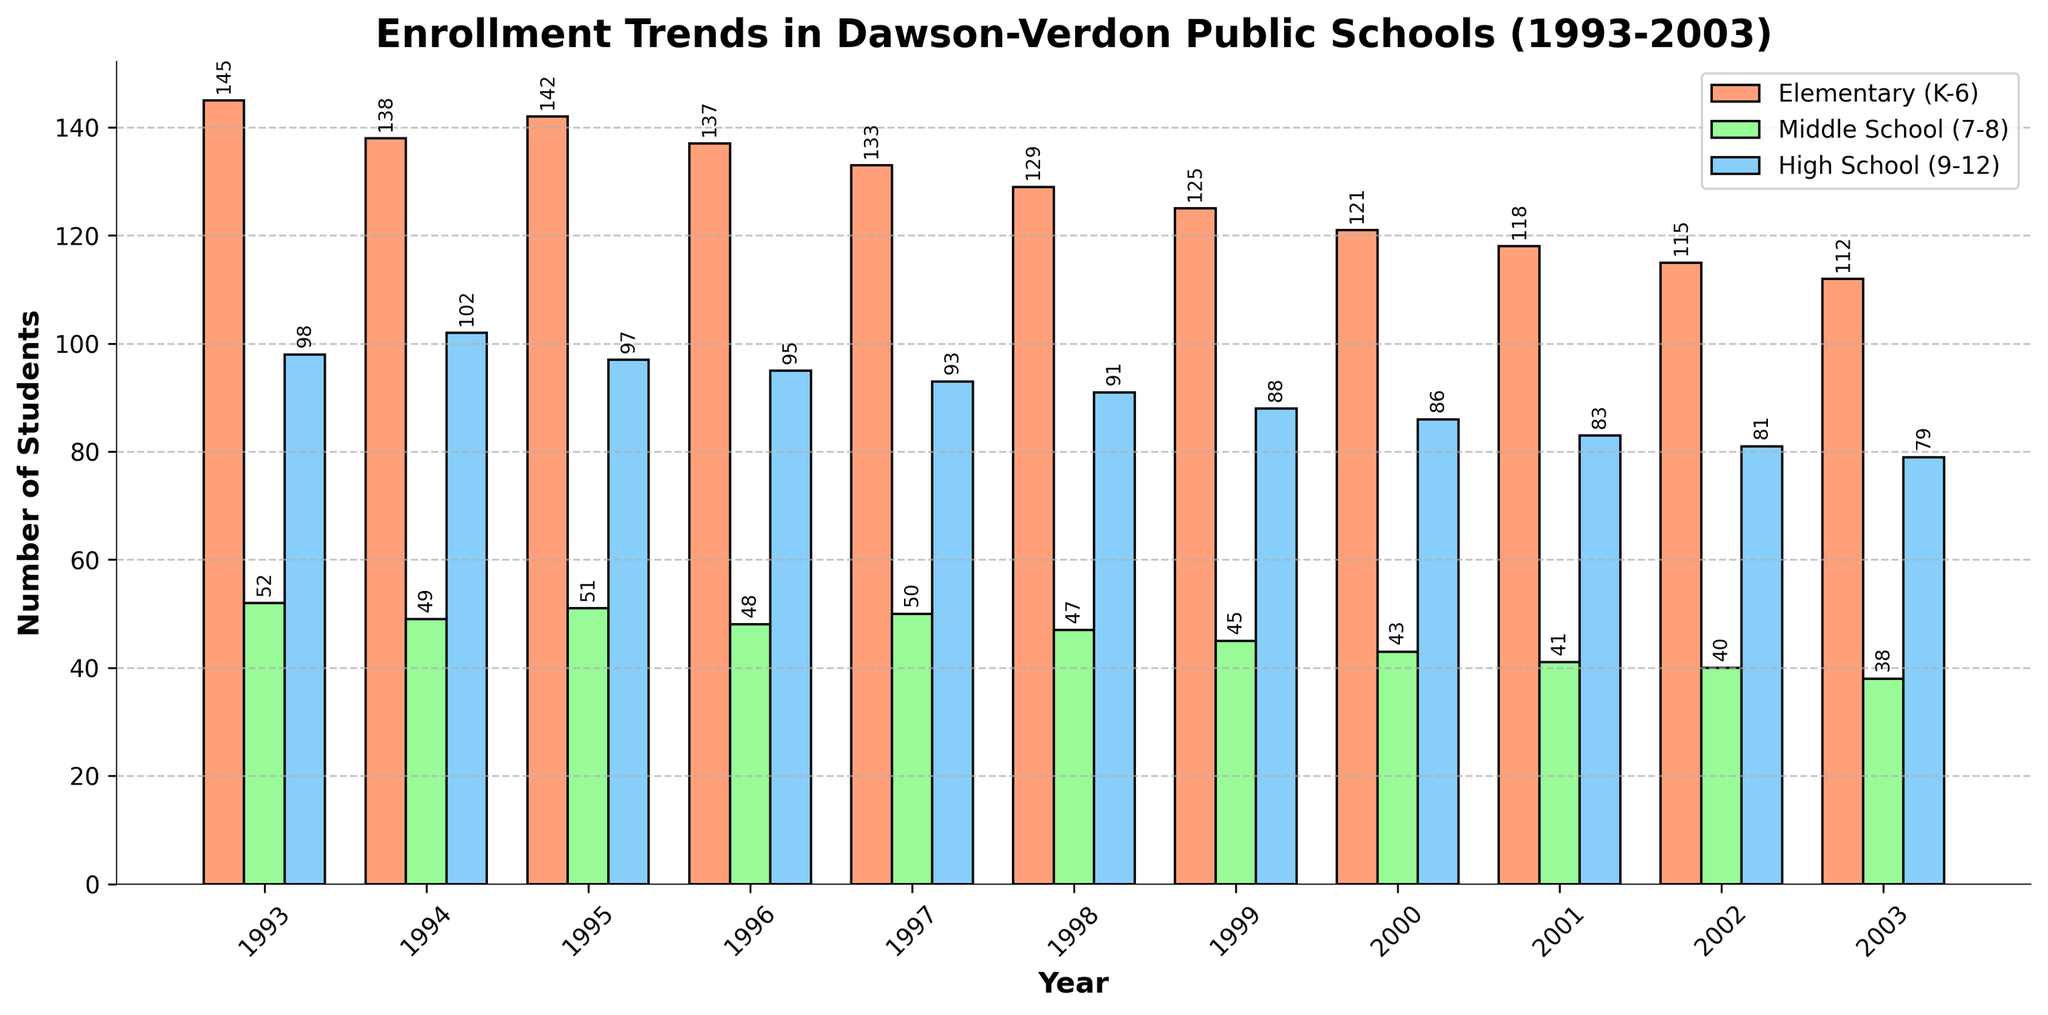What's the trend of total enrollment from 1993 to 2003? To analyze the trend, observe the heights of the bars representing the total number of students each year in the figure. Here, note that the total enrollment decreases each year from 295 in 1993 to 229 in 2003.
Answer: Decreasing trend Which grade level saw the largest decline in enrollment from 1993 to 2003? Compare the heights of the three groups of bars for 1993 and 2003. The difference in height is greatest for Elementary (K-6), which decreases from 145 in 1993 to 112 in 2003.
Answer: Elementary (K-6) What is the combined enrollment for Middle School (7-8) and High School (9-12) in 1996? Add the heights of the bars for Middle School (7-8) and High School (9-12) in 1996. The enrollment values are 48 for Middle School and 95 for High School. So, 48 + 95 = 143.
Answer: 143 In which year did the total enrollment first drop below 250? Locate the point where the total number of students' bar dips below 250. This happens in 2000, with 250 students. In the following years, it continues to be below 250.
Answer: 2001 Which grade level had the most stable enrollment over the years? Assess the fluctuation in the heights of bars for Elementary, Middle, and High School. Middle School (7-8) fluctuates the least from 52 in 1993 to 38 in 2003.
Answer: Middle School (7-8) If you combine the enrollment of Elementary and High School in 2002, does it exceed the total enrollment of 1993? First, add Elementary (115) and High School (81) enrollments in 2002, resulting in 115 + 81 = 196. Then, compare this with total enrollment in 1993, which is 295.
Answer: No, 196 < 295 By how much did the total enrollment decrease from 1993 to 1999? Subtract the total enrollment in 1999 from that in 1993. Total enrollment in 1993 is 295 and in 1999 is 258. So, 295 - 258 = 37.
Answer: 37 Which year had the highest enrollment for High School, and what was the enrollment number? Find the tallest bar for High School enrollment over the years. The tallest bar is in 1994 with 102 students enrolled.
Answer: 1994, 102 students How many students were enrolled in Middle School in 2001, and how does it compare to its enrollment in 1997? Look for the heights of the Middle School bars in 2001 and 1997. Enrollment in 2001 is 41 and in 1997 is 50. So, 50 - 41 = 9, indicating a decrease.
Answer: 41; decreased by 9 Is there any year where the enrollment of Elementary and Middle School combined was higher than the total enrollment of that year? Check if the sum of enrollment for Elementary (K-6) and Middle School (7-8) ever exceeds the total enrollment of that year. It never happens, as the sum is always less than or equal to the total enrollment.
Answer: No 